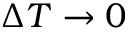<formula> <loc_0><loc_0><loc_500><loc_500>\Delta T \to 0</formula> 